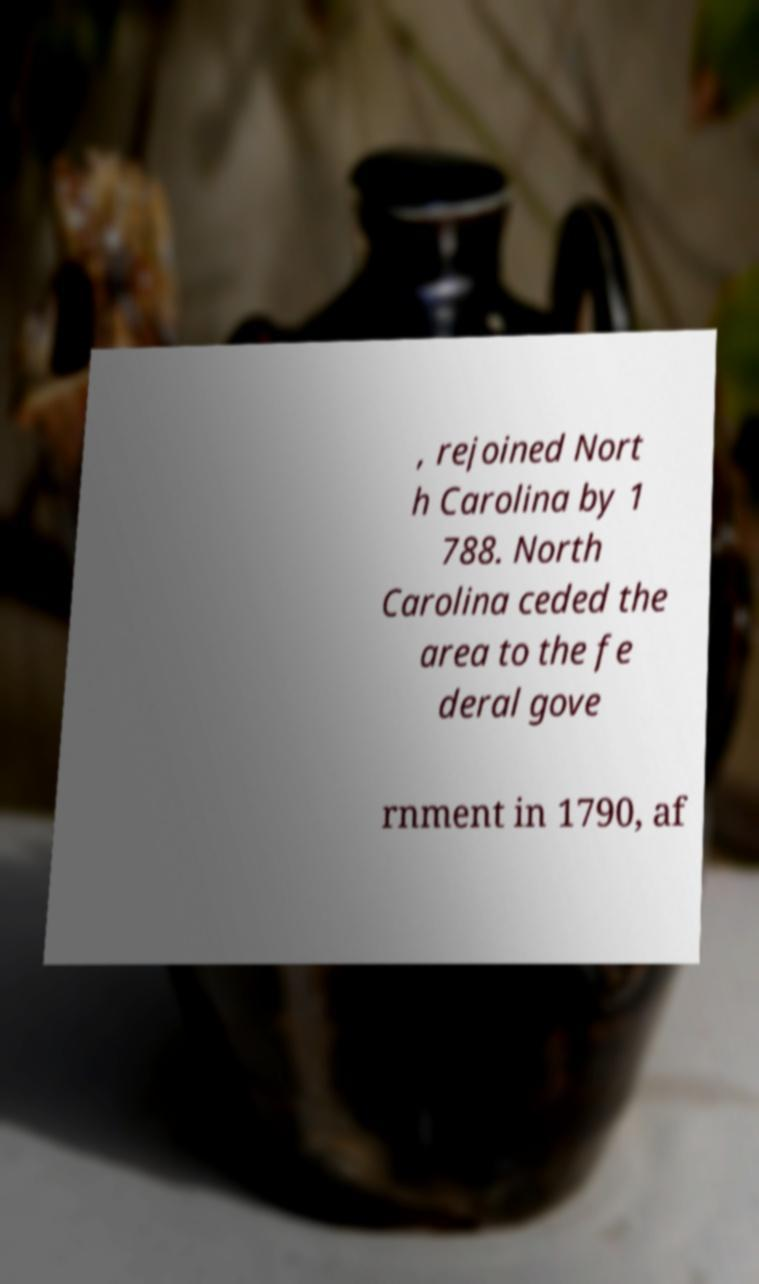Could you extract and type out the text from this image? , rejoined Nort h Carolina by 1 788. North Carolina ceded the area to the fe deral gove rnment in 1790, af 